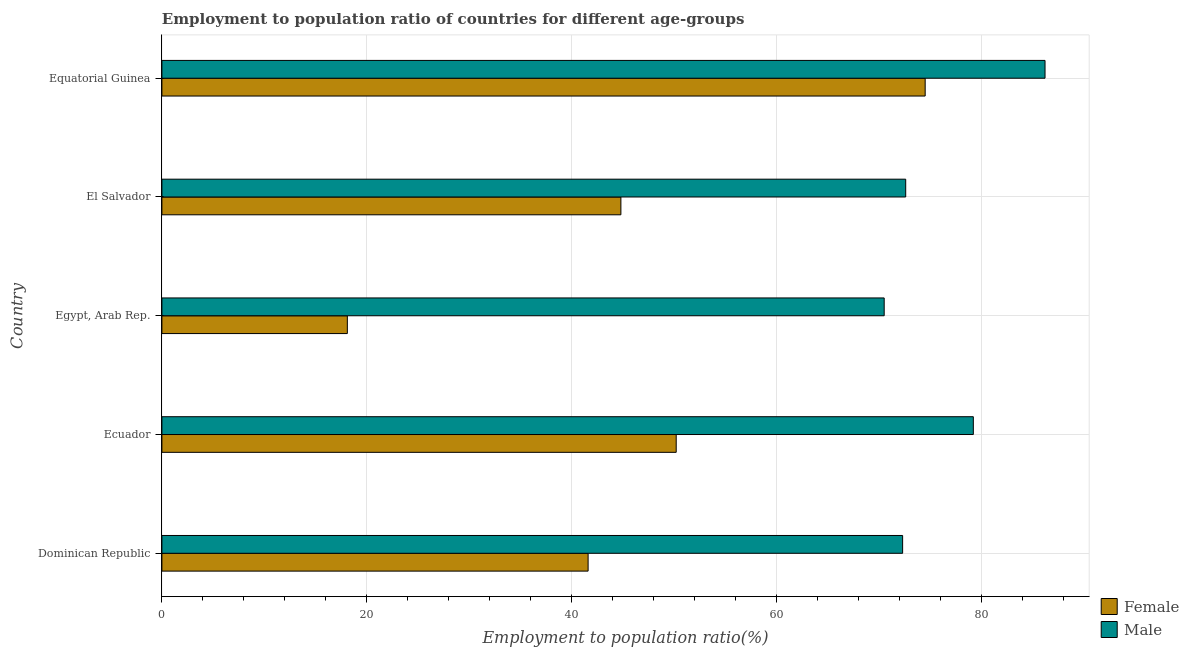How many groups of bars are there?
Your answer should be compact. 5. Are the number of bars per tick equal to the number of legend labels?
Provide a succinct answer. Yes. What is the label of the 3rd group of bars from the top?
Offer a terse response. Egypt, Arab Rep. In how many cases, is the number of bars for a given country not equal to the number of legend labels?
Your answer should be very brief. 0. What is the employment to population ratio(female) in Equatorial Guinea?
Your answer should be very brief. 74.5. Across all countries, what is the maximum employment to population ratio(male)?
Give a very brief answer. 86.2. Across all countries, what is the minimum employment to population ratio(female)?
Keep it short and to the point. 18.1. In which country was the employment to population ratio(female) maximum?
Offer a terse response. Equatorial Guinea. In which country was the employment to population ratio(male) minimum?
Your answer should be very brief. Egypt, Arab Rep. What is the total employment to population ratio(female) in the graph?
Keep it short and to the point. 229.2. What is the difference between the employment to population ratio(male) in Ecuador and that in El Salvador?
Keep it short and to the point. 6.6. What is the difference between the employment to population ratio(male) in Egypt, Arab Rep. and the employment to population ratio(female) in El Salvador?
Your response must be concise. 25.7. What is the average employment to population ratio(female) per country?
Give a very brief answer. 45.84. What is the difference between the employment to population ratio(female) and employment to population ratio(male) in El Salvador?
Make the answer very short. -27.8. In how many countries, is the employment to population ratio(female) greater than 52 %?
Make the answer very short. 1. What is the ratio of the employment to population ratio(male) in El Salvador to that in Equatorial Guinea?
Keep it short and to the point. 0.84. Is the employment to population ratio(female) in Ecuador less than that in El Salvador?
Your response must be concise. No. Is the difference between the employment to population ratio(female) in Dominican Republic and Equatorial Guinea greater than the difference between the employment to population ratio(male) in Dominican Republic and Equatorial Guinea?
Give a very brief answer. No. What is the difference between the highest and the second highest employment to population ratio(male)?
Provide a short and direct response. 7. What is the difference between the highest and the lowest employment to population ratio(male)?
Provide a short and direct response. 15.7. In how many countries, is the employment to population ratio(female) greater than the average employment to population ratio(female) taken over all countries?
Keep it short and to the point. 2. Is the sum of the employment to population ratio(female) in Dominican Republic and Ecuador greater than the maximum employment to population ratio(male) across all countries?
Your response must be concise. Yes. What does the 2nd bar from the bottom in El Salvador represents?
Offer a terse response. Male. How many countries are there in the graph?
Provide a short and direct response. 5. Does the graph contain any zero values?
Keep it short and to the point. No. Does the graph contain grids?
Make the answer very short. Yes. Where does the legend appear in the graph?
Give a very brief answer. Bottom right. How many legend labels are there?
Offer a terse response. 2. How are the legend labels stacked?
Your answer should be compact. Vertical. What is the title of the graph?
Provide a short and direct response. Employment to population ratio of countries for different age-groups. What is the Employment to population ratio(%) of Female in Dominican Republic?
Your response must be concise. 41.6. What is the Employment to population ratio(%) in Male in Dominican Republic?
Your answer should be compact. 72.3. What is the Employment to population ratio(%) of Female in Ecuador?
Make the answer very short. 50.2. What is the Employment to population ratio(%) of Male in Ecuador?
Make the answer very short. 79.2. What is the Employment to population ratio(%) in Female in Egypt, Arab Rep.?
Ensure brevity in your answer.  18.1. What is the Employment to population ratio(%) in Male in Egypt, Arab Rep.?
Ensure brevity in your answer.  70.5. What is the Employment to population ratio(%) of Female in El Salvador?
Provide a short and direct response. 44.8. What is the Employment to population ratio(%) of Male in El Salvador?
Offer a very short reply. 72.6. What is the Employment to population ratio(%) of Female in Equatorial Guinea?
Provide a short and direct response. 74.5. What is the Employment to population ratio(%) in Male in Equatorial Guinea?
Make the answer very short. 86.2. Across all countries, what is the maximum Employment to population ratio(%) of Female?
Provide a succinct answer. 74.5. Across all countries, what is the maximum Employment to population ratio(%) of Male?
Provide a short and direct response. 86.2. Across all countries, what is the minimum Employment to population ratio(%) in Female?
Your answer should be compact. 18.1. Across all countries, what is the minimum Employment to population ratio(%) of Male?
Offer a very short reply. 70.5. What is the total Employment to population ratio(%) in Female in the graph?
Your response must be concise. 229.2. What is the total Employment to population ratio(%) of Male in the graph?
Offer a terse response. 380.8. What is the difference between the Employment to population ratio(%) of Male in Dominican Republic and that in Egypt, Arab Rep.?
Ensure brevity in your answer.  1.8. What is the difference between the Employment to population ratio(%) of Female in Dominican Republic and that in Equatorial Guinea?
Keep it short and to the point. -32.9. What is the difference between the Employment to population ratio(%) of Female in Ecuador and that in Egypt, Arab Rep.?
Your answer should be very brief. 32.1. What is the difference between the Employment to population ratio(%) of Female in Ecuador and that in El Salvador?
Provide a succinct answer. 5.4. What is the difference between the Employment to population ratio(%) in Male in Ecuador and that in El Salvador?
Your answer should be very brief. 6.6. What is the difference between the Employment to population ratio(%) in Female in Ecuador and that in Equatorial Guinea?
Your answer should be very brief. -24.3. What is the difference between the Employment to population ratio(%) in Female in Egypt, Arab Rep. and that in El Salvador?
Your answer should be compact. -26.7. What is the difference between the Employment to population ratio(%) of Male in Egypt, Arab Rep. and that in El Salvador?
Give a very brief answer. -2.1. What is the difference between the Employment to population ratio(%) of Female in Egypt, Arab Rep. and that in Equatorial Guinea?
Ensure brevity in your answer.  -56.4. What is the difference between the Employment to population ratio(%) in Male in Egypt, Arab Rep. and that in Equatorial Guinea?
Offer a very short reply. -15.7. What is the difference between the Employment to population ratio(%) in Female in El Salvador and that in Equatorial Guinea?
Your answer should be very brief. -29.7. What is the difference between the Employment to population ratio(%) in Male in El Salvador and that in Equatorial Guinea?
Keep it short and to the point. -13.6. What is the difference between the Employment to population ratio(%) in Female in Dominican Republic and the Employment to population ratio(%) in Male in Ecuador?
Keep it short and to the point. -37.6. What is the difference between the Employment to population ratio(%) of Female in Dominican Republic and the Employment to population ratio(%) of Male in Egypt, Arab Rep.?
Make the answer very short. -28.9. What is the difference between the Employment to population ratio(%) of Female in Dominican Republic and the Employment to population ratio(%) of Male in El Salvador?
Your response must be concise. -31. What is the difference between the Employment to population ratio(%) of Female in Dominican Republic and the Employment to population ratio(%) of Male in Equatorial Guinea?
Provide a succinct answer. -44.6. What is the difference between the Employment to population ratio(%) of Female in Ecuador and the Employment to population ratio(%) of Male in Egypt, Arab Rep.?
Provide a succinct answer. -20.3. What is the difference between the Employment to population ratio(%) in Female in Ecuador and the Employment to population ratio(%) in Male in El Salvador?
Give a very brief answer. -22.4. What is the difference between the Employment to population ratio(%) of Female in Ecuador and the Employment to population ratio(%) of Male in Equatorial Guinea?
Your answer should be compact. -36. What is the difference between the Employment to population ratio(%) in Female in Egypt, Arab Rep. and the Employment to population ratio(%) in Male in El Salvador?
Keep it short and to the point. -54.5. What is the difference between the Employment to population ratio(%) in Female in Egypt, Arab Rep. and the Employment to population ratio(%) in Male in Equatorial Guinea?
Provide a succinct answer. -68.1. What is the difference between the Employment to population ratio(%) in Female in El Salvador and the Employment to population ratio(%) in Male in Equatorial Guinea?
Keep it short and to the point. -41.4. What is the average Employment to population ratio(%) in Female per country?
Your response must be concise. 45.84. What is the average Employment to population ratio(%) of Male per country?
Offer a very short reply. 76.16. What is the difference between the Employment to population ratio(%) in Female and Employment to population ratio(%) in Male in Dominican Republic?
Provide a short and direct response. -30.7. What is the difference between the Employment to population ratio(%) of Female and Employment to population ratio(%) of Male in Egypt, Arab Rep.?
Make the answer very short. -52.4. What is the difference between the Employment to population ratio(%) of Female and Employment to population ratio(%) of Male in El Salvador?
Offer a terse response. -27.8. What is the difference between the Employment to population ratio(%) in Female and Employment to population ratio(%) in Male in Equatorial Guinea?
Provide a succinct answer. -11.7. What is the ratio of the Employment to population ratio(%) in Female in Dominican Republic to that in Ecuador?
Your response must be concise. 0.83. What is the ratio of the Employment to population ratio(%) of Male in Dominican Republic to that in Ecuador?
Give a very brief answer. 0.91. What is the ratio of the Employment to population ratio(%) in Female in Dominican Republic to that in Egypt, Arab Rep.?
Provide a succinct answer. 2.3. What is the ratio of the Employment to population ratio(%) of Male in Dominican Republic to that in Egypt, Arab Rep.?
Provide a short and direct response. 1.03. What is the ratio of the Employment to population ratio(%) of Female in Dominican Republic to that in El Salvador?
Provide a succinct answer. 0.93. What is the ratio of the Employment to population ratio(%) of Male in Dominican Republic to that in El Salvador?
Give a very brief answer. 1. What is the ratio of the Employment to population ratio(%) in Female in Dominican Republic to that in Equatorial Guinea?
Make the answer very short. 0.56. What is the ratio of the Employment to population ratio(%) in Male in Dominican Republic to that in Equatorial Guinea?
Your response must be concise. 0.84. What is the ratio of the Employment to population ratio(%) in Female in Ecuador to that in Egypt, Arab Rep.?
Offer a very short reply. 2.77. What is the ratio of the Employment to population ratio(%) in Male in Ecuador to that in Egypt, Arab Rep.?
Offer a very short reply. 1.12. What is the ratio of the Employment to population ratio(%) in Female in Ecuador to that in El Salvador?
Offer a very short reply. 1.12. What is the ratio of the Employment to population ratio(%) of Male in Ecuador to that in El Salvador?
Your response must be concise. 1.09. What is the ratio of the Employment to population ratio(%) of Female in Ecuador to that in Equatorial Guinea?
Keep it short and to the point. 0.67. What is the ratio of the Employment to population ratio(%) in Male in Ecuador to that in Equatorial Guinea?
Offer a very short reply. 0.92. What is the ratio of the Employment to population ratio(%) in Female in Egypt, Arab Rep. to that in El Salvador?
Make the answer very short. 0.4. What is the ratio of the Employment to population ratio(%) in Male in Egypt, Arab Rep. to that in El Salvador?
Your answer should be very brief. 0.97. What is the ratio of the Employment to population ratio(%) of Female in Egypt, Arab Rep. to that in Equatorial Guinea?
Your response must be concise. 0.24. What is the ratio of the Employment to population ratio(%) of Male in Egypt, Arab Rep. to that in Equatorial Guinea?
Ensure brevity in your answer.  0.82. What is the ratio of the Employment to population ratio(%) in Female in El Salvador to that in Equatorial Guinea?
Offer a very short reply. 0.6. What is the ratio of the Employment to population ratio(%) of Male in El Salvador to that in Equatorial Guinea?
Make the answer very short. 0.84. What is the difference between the highest and the second highest Employment to population ratio(%) of Female?
Make the answer very short. 24.3. What is the difference between the highest and the second highest Employment to population ratio(%) of Male?
Your answer should be very brief. 7. What is the difference between the highest and the lowest Employment to population ratio(%) of Female?
Ensure brevity in your answer.  56.4. What is the difference between the highest and the lowest Employment to population ratio(%) of Male?
Ensure brevity in your answer.  15.7. 